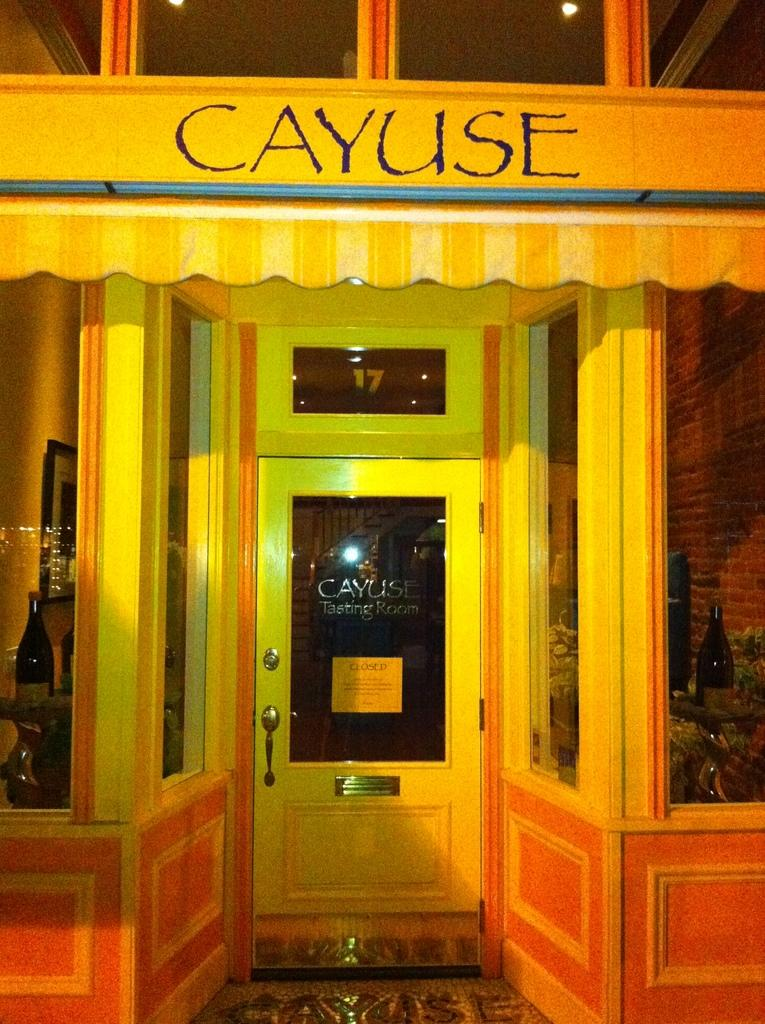What is located in the middle of the image? There is a door in the middle of the image. What feature does the door appear to have? The door appears to have a bar. What can be seen on either side of the image? There are wine bottles on either side of the image. What is present at the top of the image? There is a yellow color board at the top of the image. What information is provided on the yellow color board? The name is written on the yellow color board. What type of railway is visible in the image? There is no railway present in the image. How many laborers can be seen working in the image? There are no laborers present in the image. 